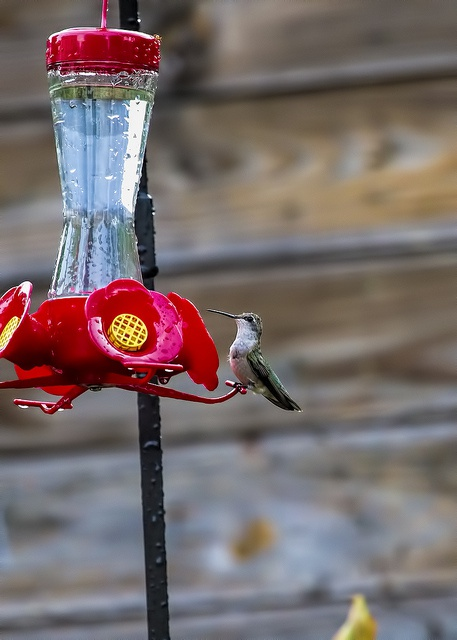Describe the objects in this image and their specific colors. I can see a bird in gray, black, and darkgray tones in this image. 